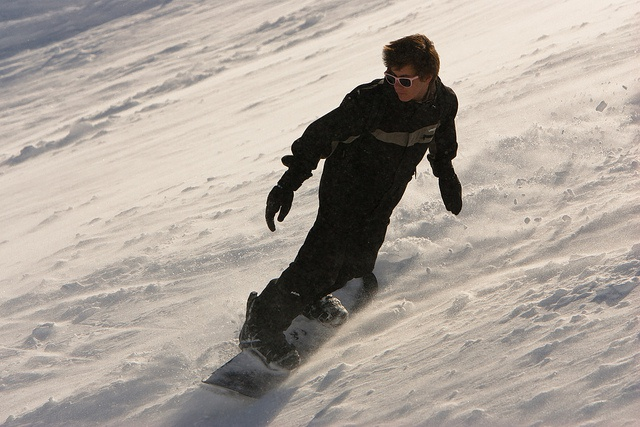Describe the objects in this image and their specific colors. I can see people in gray, black, maroon, and lightgray tones and snowboard in gray and black tones in this image. 